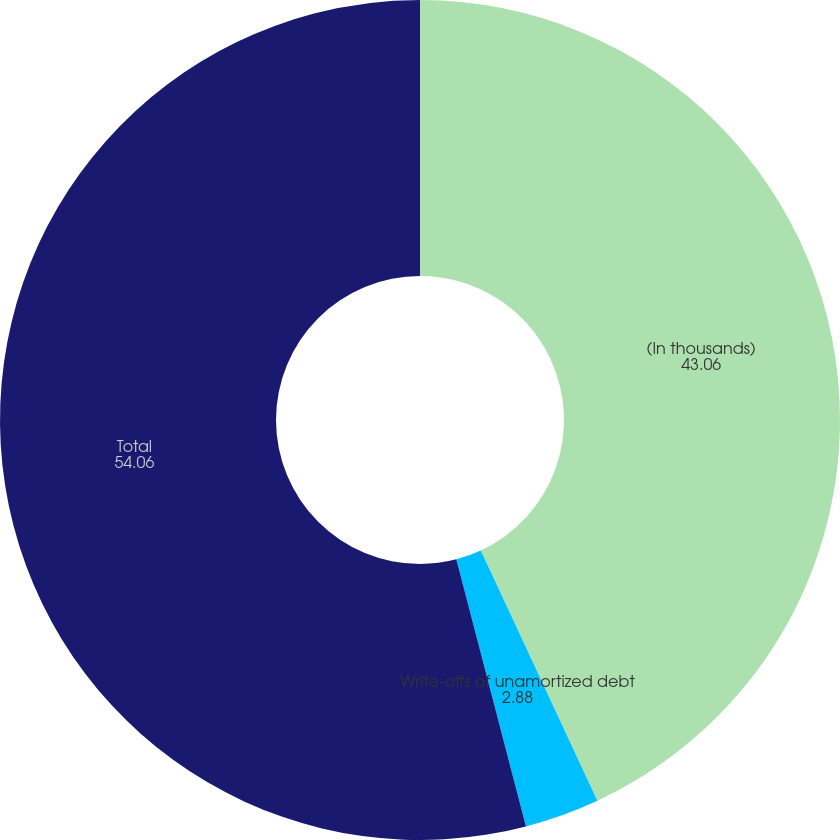Convert chart. <chart><loc_0><loc_0><loc_500><loc_500><pie_chart><fcel>(In thousands)<fcel>Write-offs of unamortized debt<fcel>Total<nl><fcel>43.06%<fcel>2.88%<fcel>54.06%<nl></chart> 